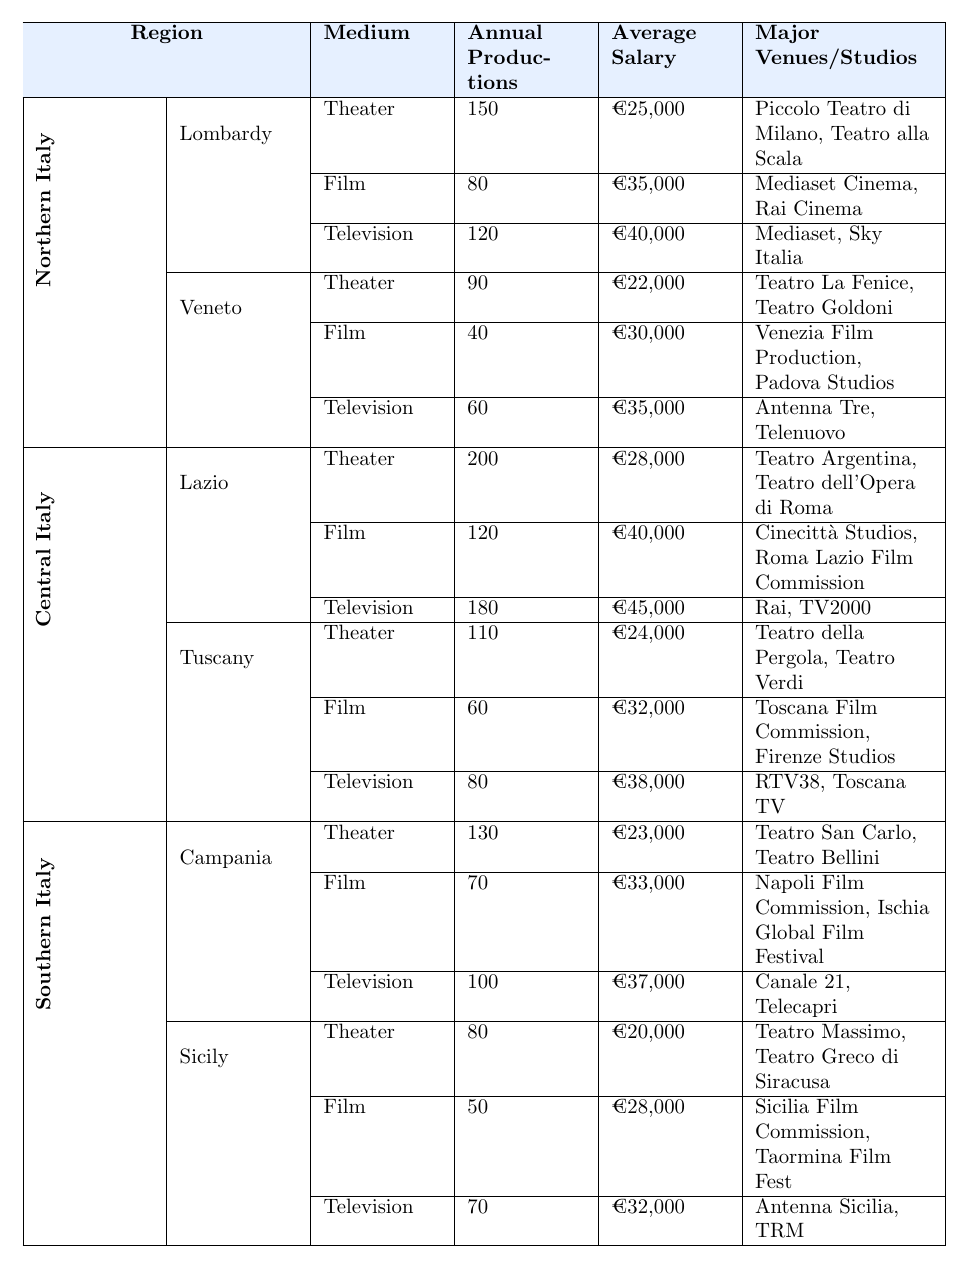What's the average salary for actors in Lazio? The average salary for actors in Lazio is listed as €28,000 for theater, €40,000 for film, and €45,000 for television. To find the average, sum these amounts (28,000 + 40,000 + 45,000 = 113,000) and divide by the number of mediums (3): 113,000 / 3 = €37,667.
Answer: €37,667 Which region has the highest annual productions in television? The table shows that Lazio has 180 annual television productions, which is higher than any other region listed.
Answer: Lazio How many major theaters are in Northern Italy? In Lombardy, there are 2 major theaters; in Veneto, there are also 2 major theaters. Adding these gives a total of 2 + 2 = 4 major theaters in Northern Italy.
Answer: 4 Is the average salary for actors in Southern Italy lower than in Northern Italy? In Southern Italy, the average salaries are €23,000 (theater), €33,000 (film), and €37,000 (television). In Northern Italy, the average salaries are €25,000 (theater), €35,000 (film), and €40,000 (television). Comparing each, Southern Italy has lower average salaries in all three categories.
Answer: Yes How many more annual film productions are there in Lazio compared to Sicily? Lazio has 120 film productions, while Sicily has 50. Subtracting gives 120 - 50 = 70 more productions in Lazio compared to Sicily.
Answer: 70 What is the combined total of annual theater productions in Central Italy? In Central Italy, Lazio has 200 theater productions and Tuscany has 110. Adding these gives 200 + 110 = 310 annual theater productions in Central Italy.
Answer: 310 Which major theater in Veneto has the lowest average salary for actors compared to the other regions? The average salary in Veneto for theater is €22,000, which is lower than Lombardy (€25,000) and Lazio (€28,000). Comparing with southern regions, Campania has €23,000 and Sicily has €20,000. Therefore, Teatro Massimo (Sicily) has the lowest salary of €20,000.
Answer: Teatro Massimo What is the difference in annual productions between Northern Italy's Lombardy and Southern Italy's Campania? Lombardy has 150 annual productions in theater, 80 in film, and 120 in television, totaling 350. Campania has 130 in theater, 70 in film, and 100 in television, totaling 300. The difference is 350 - 300 = 50.
Answer: 50 Is it true that Veneto produces more films annually than Campania? Veneto produces 40 films annually while Campania produces 70 films. Since 40 is less than 70, the statement is false.
Answer: No What are the average salaries across all mediums for all regions, and which region has the highest average? To find the averages: Northern Italy (Theater: €25,000, Film: €35,000, Television: €40,000), Central Italy (Theater: €28,000, Film: €40,000, Television: €45,000), Southern Italy (Theater: €23,000, Film: €33,000, Television: €37,000). Calculate averages: Northern (€100,000 / 3 = €33,333), Central (€113,000 / 3 = €37,667), Southern (€93,000 / 3 = €31,000). The highest average is in Central Italy.
Answer: Central Italy 